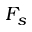Convert formula to latex. <formula><loc_0><loc_0><loc_500><loc_500>F _ { s }</formula> 